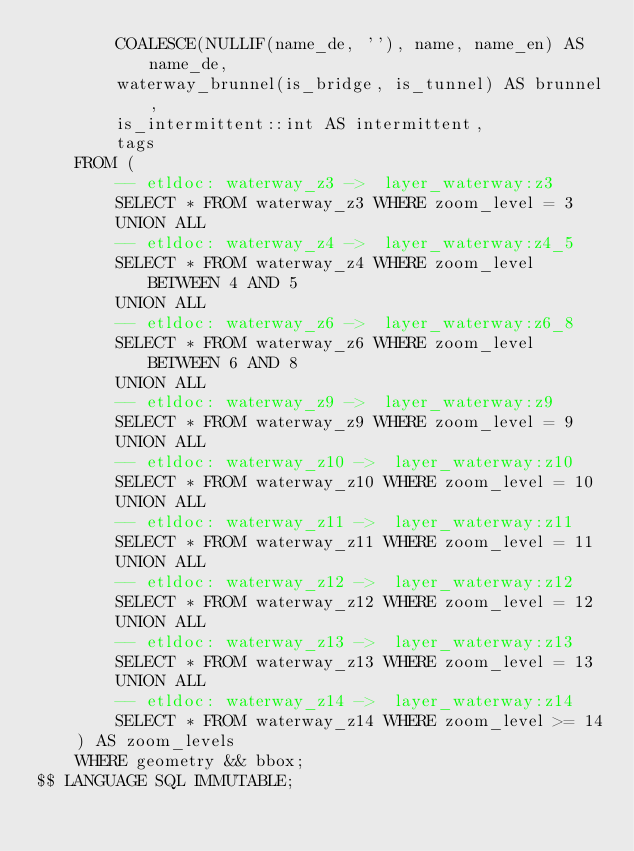Convert code to text. <code><loc_0><loc_0><loc_500><loc_500><_SQL_>        COALESCE(NULLIF(name_de, ''), name, name_en) AS name_de,
        waterway_brunnel(is_bridge, is_tunnel) AS brunnel,
        is_intermittent::int AS intermittent,
        tags
    FROM (
        -- etldoc: waterway_z3 ->  layer_waterway:z3
        SELECT * FROM waterway_z3 WHERE zoom_level = 3
        UNION ALL
        -- etldoc: waterway_z4 ->  layer_waterway:z4_5
        SELECT * FROM waterway_z4 WHERE zoom_level BETWEEN 4 AND 5
        UNION ALL
        -- etldoc: waterway_z6 ->  layer_waterway:z6_8
        SELECT * FROM waterway_z6 WHERE zoom_level BETWEEN 6 AND 8
        UNION ALL
        -- etldoc: waterway_z9 ->  layer_waterway:z9
        SELECT * FROM waterway_z9 WHERE zoom_level = 9
        UNION ALL
        -- etldoc: waterway_z10 ->  layer_waterway:z10
        SELECT * FROM waterway_z10 WHERE zoom_level = 10
        UNION ALL
        -- etldoc: waterway_z11 ->  layer_waterway:z11
        SELECT * FROM waterway_z11 WHERE zoom_level = 11
        UNION ALL
        -- etldoc: waterway_z12 ->  layer_waterway:z12
        SELECT * FROM waterway_z12 WHERE zoom_level = 12
        UNION ALL
        -- etldoc: waterway_z13 ->  layer_waterway:z13
        SELECT * FROM waterway_z13 WHERE zoom_level = 13
        UNION ALL
        -- etldoc: waterway_z14 ->  layer_waterway:z14
        SELECT * FROM waterway_z14 WHERE zoom_level >= 14
    ) AS zoom_levels
    WHERE geometry && bbox;
$$ LANGUAGE SQL IMMUTABLE;
</code> 